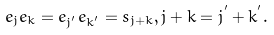Convert formula to latex. <formula><loc_0><loc_0><loc_500><loc_500>e _ { j } e _ { k } = e _ { j ^ { ^ { \prime } } } e _ { k ^ { ^ { \prime } } } = s _ { j + k } , j + k = j ^ { ^ { \prime } } + k ^ { ^ { \prime } } .</formula> 